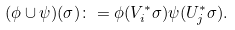Convert formula to latex. <formula><loc_0><loc_0><loc_500><loc_500>( \phi \cup \psi ) ( \sigma ) \colon = \phi ( V _ { i } ^ { * } \sigma ) \psi ( U _ { j } ^ { * } \sigma ) .</formula> 